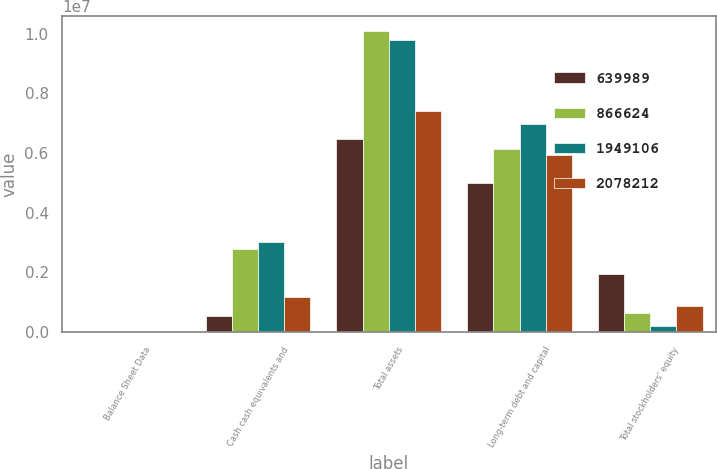Convert chart. <chart><loc_0><loc_0><loc_500><loc_500><stacked_bar_chart><ecel><fcel>Balance Sheet Data<fcel>Cash cash equivalents and<fcel>Total assets<fcel>Long-term debt and capital<fcel>Total stockholders' equity<nl><fcel>639989<fcel>2008<fcel>559132<fcel>6.46005e+06<fcel>5.00776e+06<fcel>1.94911e+06<nl><fcel>866624<fcel>2007<fcel>2.7882e+06<fcel>1.00865e+07<fcel>6.1257e+06<fcel>639989<nl><fcel>1.94911e+06<fcel>2006<fcel>3.03257e+06<fcel>9.7687e+06<fcel>6.96732e+06<fcel>219383<nl><fcel>2.07821e+06<fcel>2005<fcel>1.18136e+06<fcel>7.41021e+06<fcel>5.9353e+06<fcel>866624<nl></chart> 